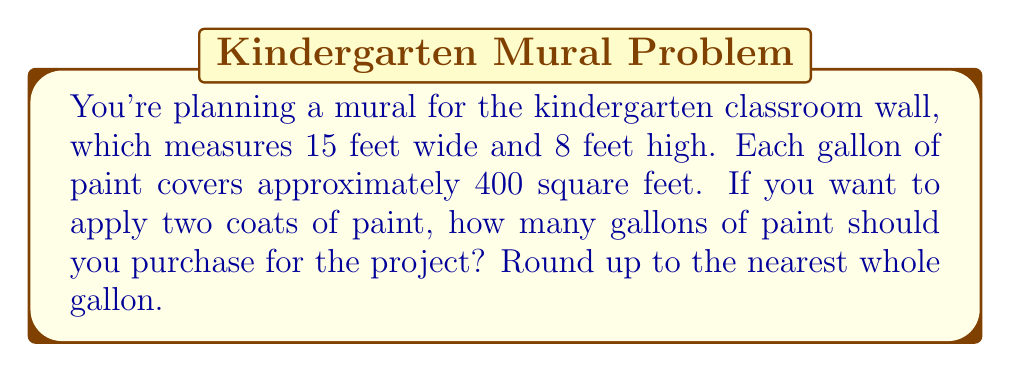Give your solution to this math problem. Let's approach this step-by-step:

1. Calculate the area of the wall:
   Area = width × height
   $$ A = 15 \text{ ft} \times 8 \text{ ft} = 120 \text{ sq ft} $$

2. Determine the total area to be painted, considering two coats:
   Total area = Wall area × Number of coats
   $$ A_{total} = 120 \text{ sq ft} \times 2 = 240 \text{ sq ft} $$

3. Calculate the number of gallons needed:
   Gallons = Total area ÷ Coverage per gallon
   $$ G = \frac{240 \text{ sq ft}}{400 \text{ sq ft/gal}} = 0.6 \text{ gal} $$

4. Round up to the nearest whole gallon:
   $$ G_{rounded} = \lceil 0.6 \rceil = 1 \text{ gal} $$

Therefore, you should purchase 1 gallon of paint for the mural project.
Answer: 1 gallon 